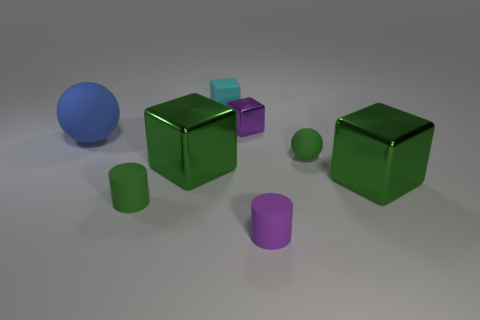Subtract all purple cubes. How many cubes are left? 3 Subtract 1 blocks. How many blocks are left? 3 Subtract all purple blocks. How many blocks are left? 3 Subtract all brown blocks. Subtract all cyan balls. How many blocks are left? 4 Add 1 rubber cylinders. How many objects exist? 9 Subtract all balls. How many objects are left? 6 Add 2 purple shiny things. How many purple shiny things are left? 3 Add 7 big rubber spheres. How many big rubber spheres exist? 8 Subtract 0 gray cubes. How many objects are left? 8 Subtract all purple shiny objects. Subtract all purple objects. How many objects are left? 5 